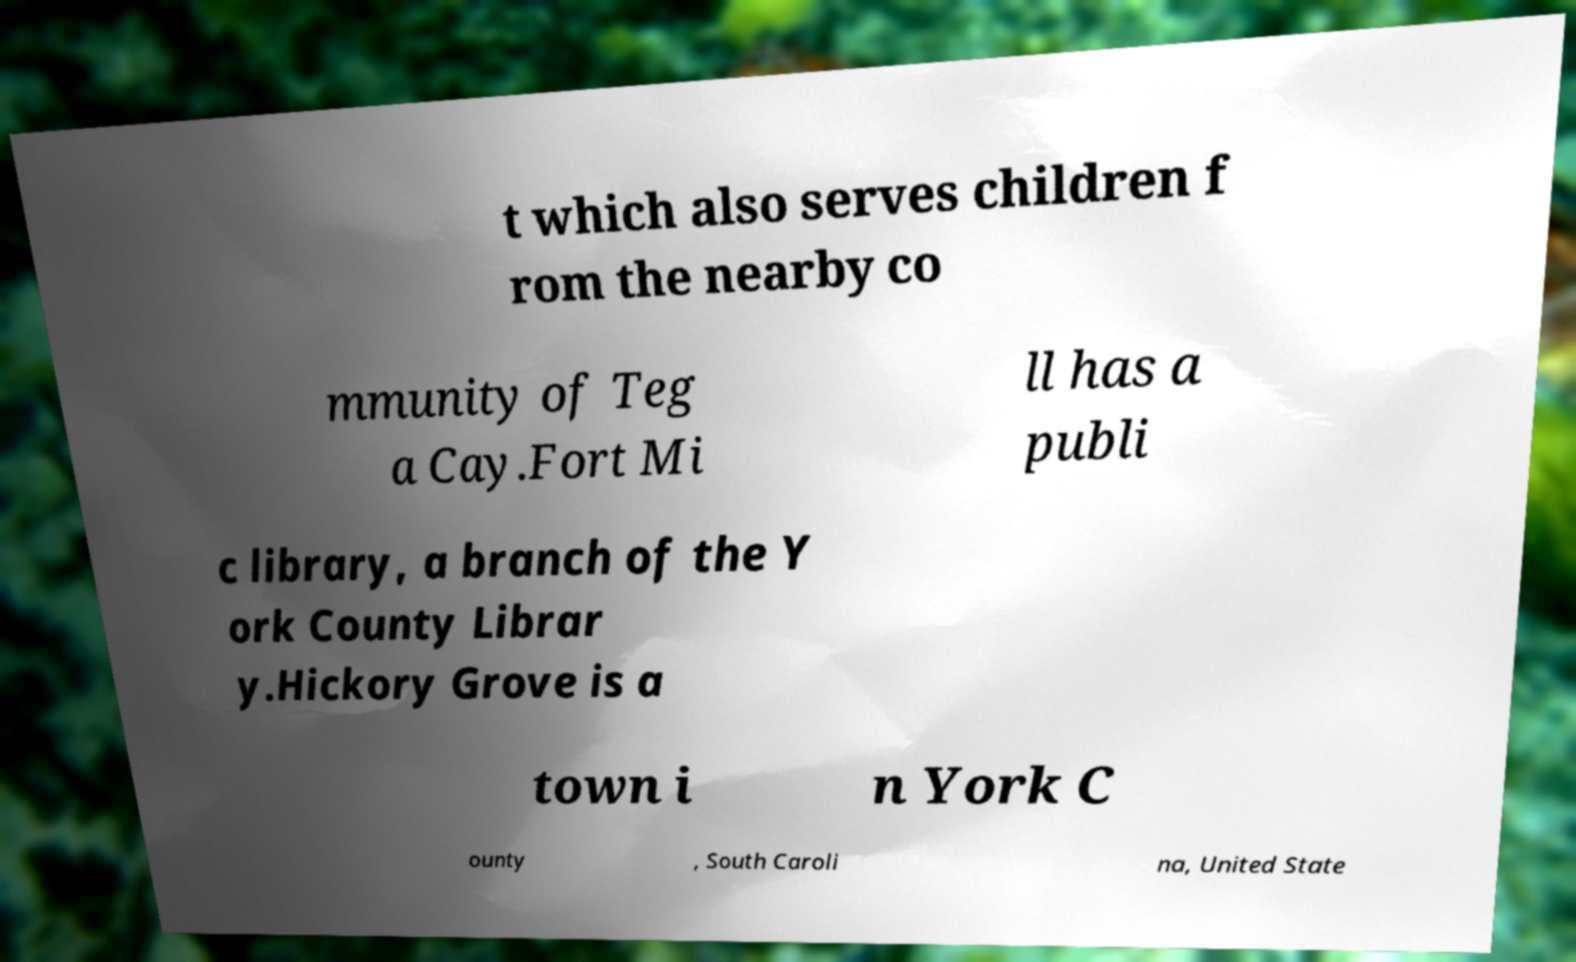I need the written content from this picture converted into text. Can you do that? t which also serves children f rom the nearby co mmunity of Teg a Cay.Fort Mi ll has a publi c library, a branch of the Y ork County Librar y.Hickory Grove is a town i n York C ounty , South Caroli na, United State 